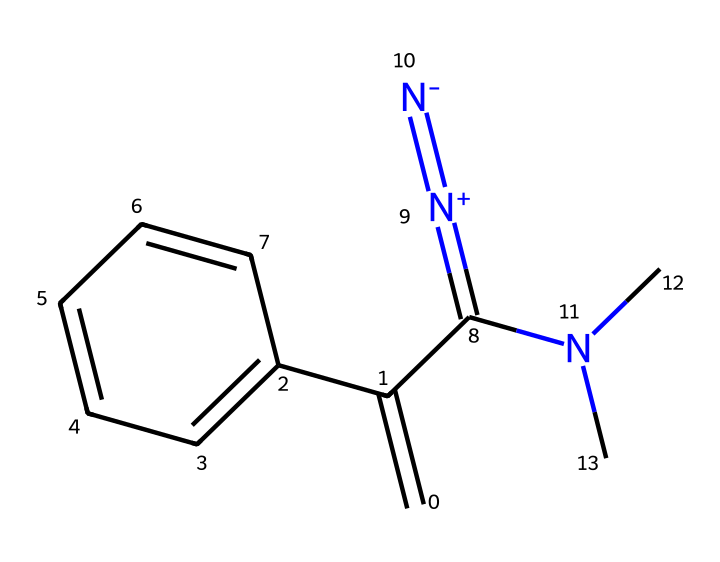What type of functional group is present in this compound? The presence of a nitrogen atom in the molecule indicates that there is an amine functional group involved, while the presence of an alkene indicates unsaturation. Both groups are key in understanding the chemical's reactivity.
Answer: amine and alkene How many aromatic rings are in the chemical structure? By examining the structure closely, we can identify that there is one aromatic ring which is represented by the benzene moiety in the structure.
Answer: one What is the degree of unsaturation in this compound? To calculate the degree of unsaturation, we consider the number of rings and double bonds. In this case, there is one double bond (C=C) and one aromatic ring, which contributes to the unsaturation. The calculation would give a total of two.
Answer: two What is the charge of the nitrogen in the [N+]=[N-] group? The presence of [N+]=[N-] indicates that the nitrogen on the left is positively charged, while the nitrogen on the right is negatively charged, reflecting a charge transfer between them.
Answer: positive and negative Is this compound expected to be stable or a reactive intermediate? Given the presence of a carbene and the way it is structured, it is expected to be a reactive intermediate that is transient in nature, playing a vital role during chemical reactions.
Answer: reactive intermediate What role do carbenes play in synthesizing UV-resistant inks? Carbenes are known to be intermediates in polymerization reactions, mainly because they can initiate free radical formation and contribute to crosslinking, which enhances the UV resistance of the final product.
Answer: initiators of polymerization 